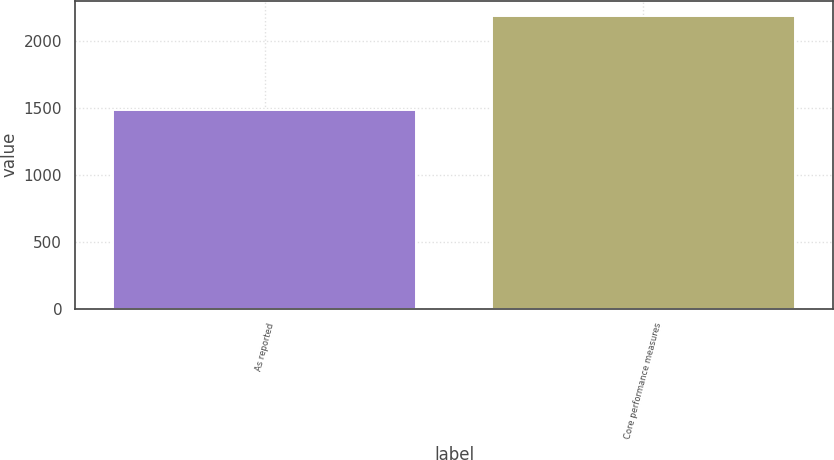<chart> <loc_0><loc_0><loc_500><loc_500><bar_chart><fcel>As reported<fcel>Core performance measures<nl><fcel>1486<fcel>2190<nl></chart> 